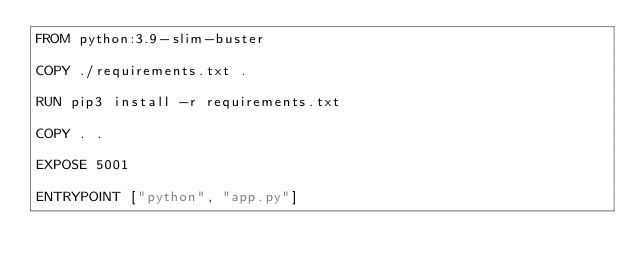Convert code to text. <code><loc_0><loc_0><loc_500><loc_500><_Dockerfile_>FROM python:3.9-slim-buster

COPY ./requirements.txt .

RUN pip3 install -r requirements.txt

COPY . .

EXPOSE 5001

ENTRYPOINT ["python", "app.py"]
</code> 